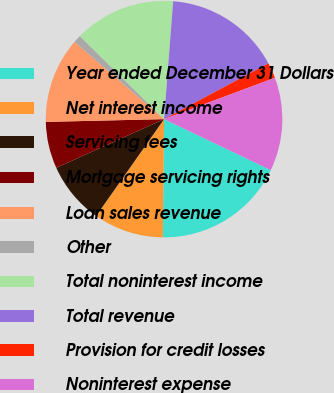<chart> <loc_0><loc_0><loc_500><loc_500><pie_chart><fcel>Year ended December 31 Dollars<fcel>Net interest income<fcel>Servicing fees<fcel>Mortgage servicing rights<fcel>Loan sales revenue<fcel>Other<fcel>Total noninterest income<fcel>Total revenue<fcel>Provision for credit losses<fcel>Noninterest expense<nl><fcel>18.08%<fcel>9.57%<fcel>8.51%<fcel>6.38%<fcel>11.7%<fcel>1.07%<fcel>13.83%<fcel>15.96%<fcel>2.13%<fcel>12.77%<nl></chart> 